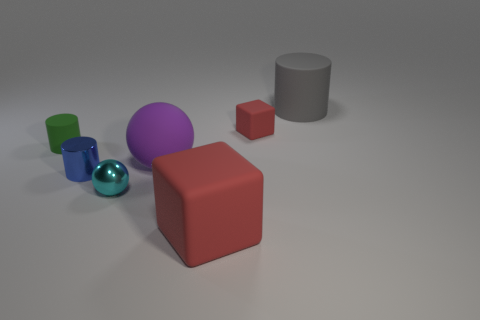There is a big thing that is behind the big purple ball; what is it made of?
Offer a very short reply. Rubber. Are the blue cylinder to the right of the tiny rubber cylinder and the big sphere behind the tiny blue cylinder made of the same material?
Give a very brief answer. No. Are there the same number of small green cylinders that are in front of the small cyan metal thing and large purple balls that are right of the small red thing?
Make the answer very short. Yes. How many large red cubes have the same material as the blue cylinder?
Offer a terse response. 0. The tiny matte object that is the same color as the big rubber cube is what shape?
Your response must be concise. Cube. There is a matte cylinder on the left side of the tiny object behind the green matte object; what is its size?
Offer a very short reply. Small. Do the tiny rubber object that is on the left side of the big ball and the red thing that is in front of the tiny blue metal object have the same shape?
Keep it short and to the point. No. Are there the same number of large gray matte cylinders on the left side of the shiny cylinder and purple matte balls?
Keep it short and to the point. No. What color is the other thing that is the same shape as the cyan shiny object?
Your answer should be very brief. Purple. Does the cylinder that is to the right of the tiny red matte thing have the same material as the green thing?
Give a very brief answer. Yes. 